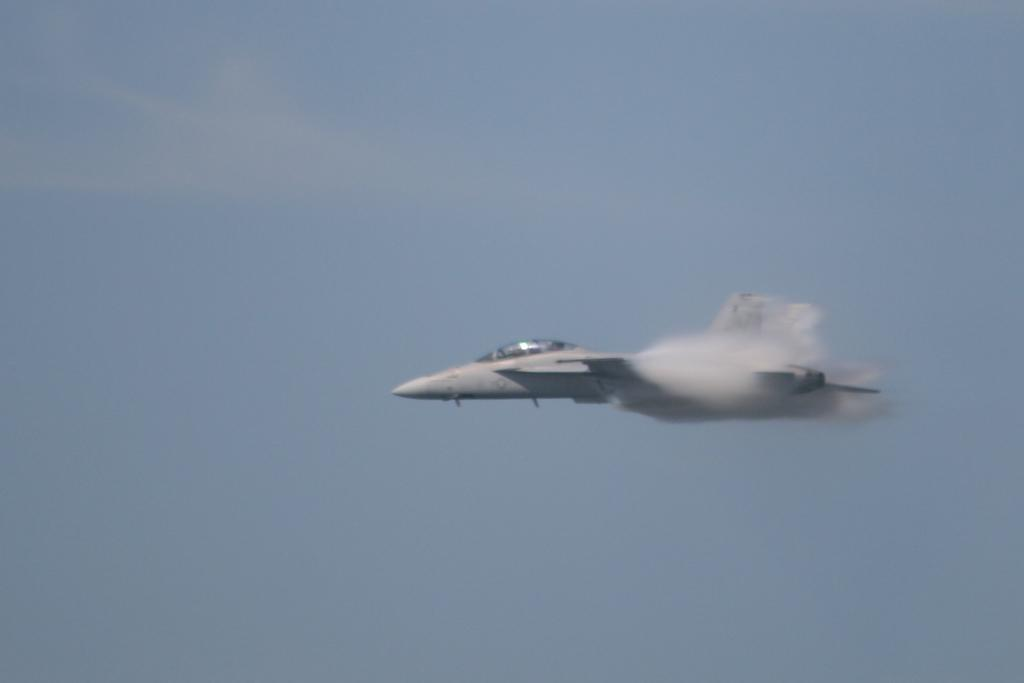What is the main subject of the image? The main subject of the image is a jet plane. Where is the jet plane located in the image? The jet plane is in the sky. How would you describe the sky in the image? The sky appears cloudy in the image. What type of holiday is being celebrated in the image? There is no indication of a holiday being celebrated in the image, as it only features a jet plane in the sky with a cloudy background. 